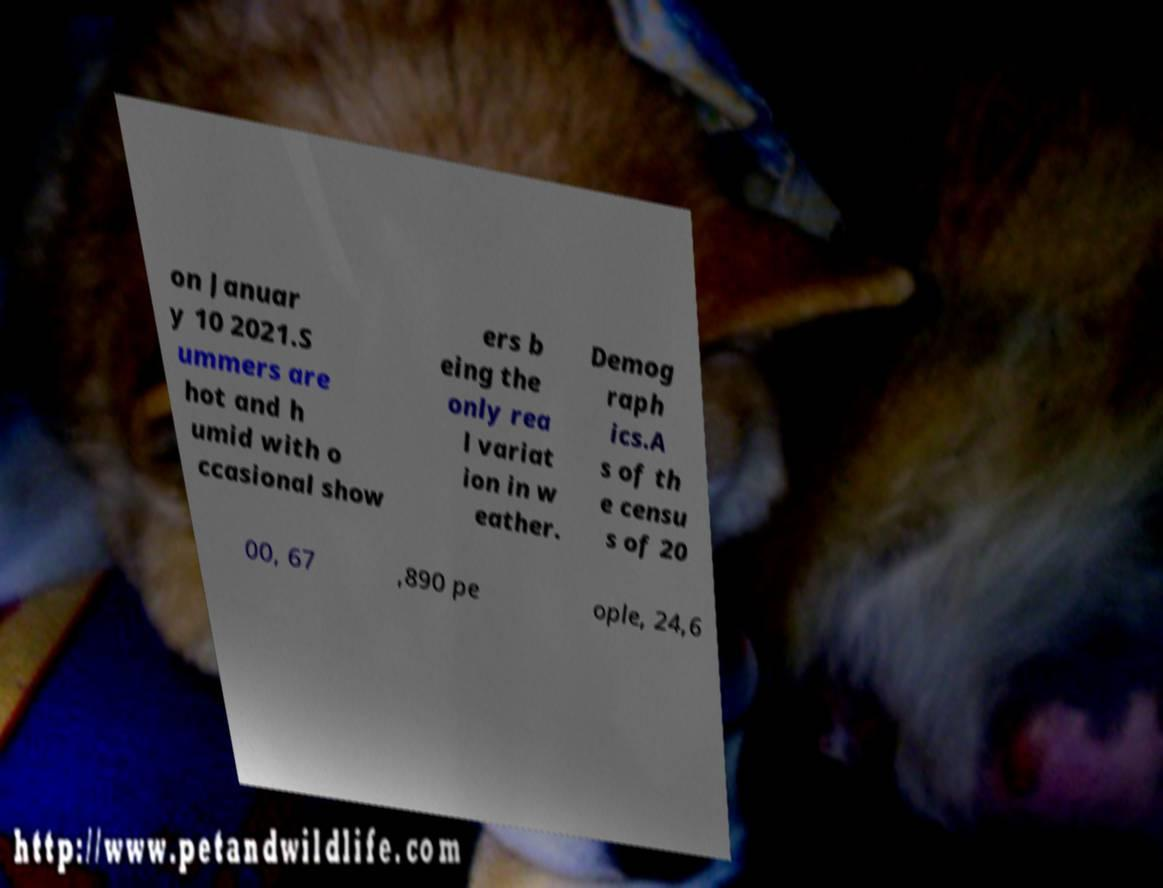Can you read and provide the text displayed in the image?This photo seems to have some interesting text. Can you extract and type it out for me? on Januar y 10 2021.S ummers are hot and h umid with o ccasional show ers b eing the only rea l variat ion in w eather. Demog raph ics.A s of th e censu s of 20 00, 67 ,890 pe ople, 24,6 